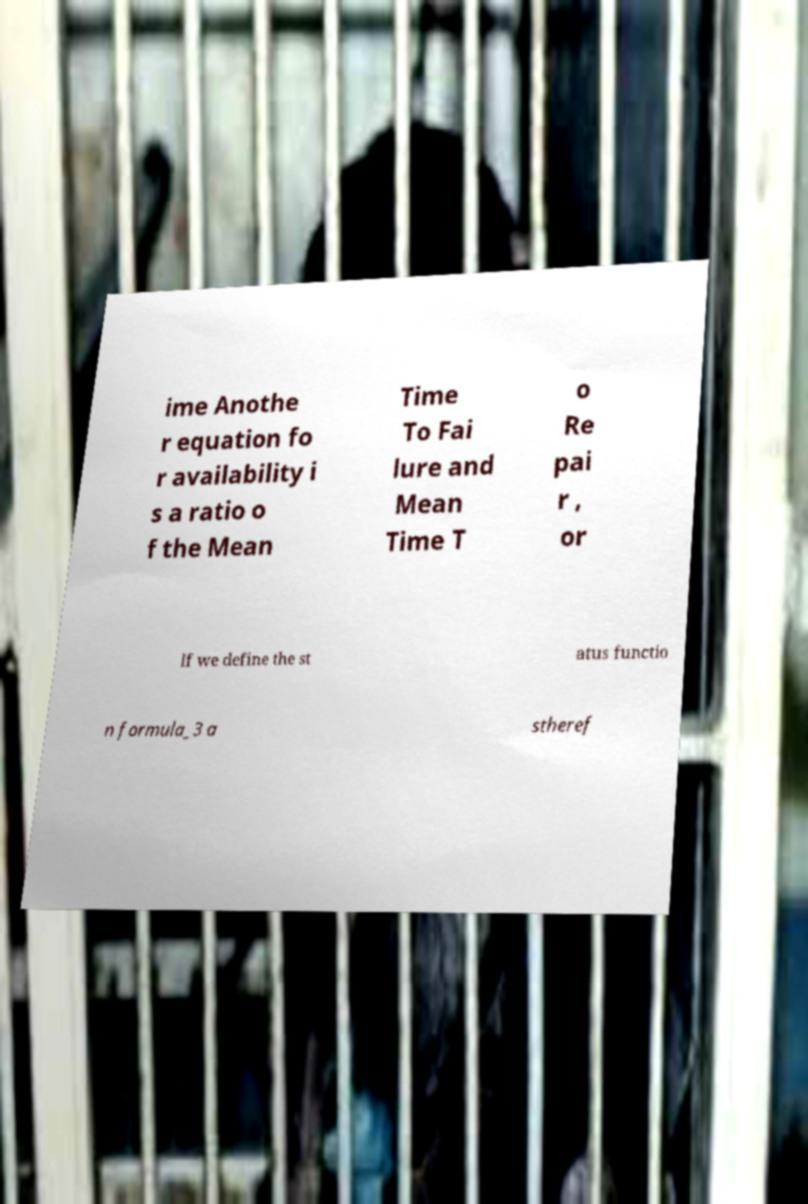Can you accurately transcribe the text from the provided image for me? ime Anothe r equation fo r availability i s a ratio o f the Mean Time To Fai lure and Mean Time T o Re pai r , or If we define the st atus functio n formula_3 a stheref 